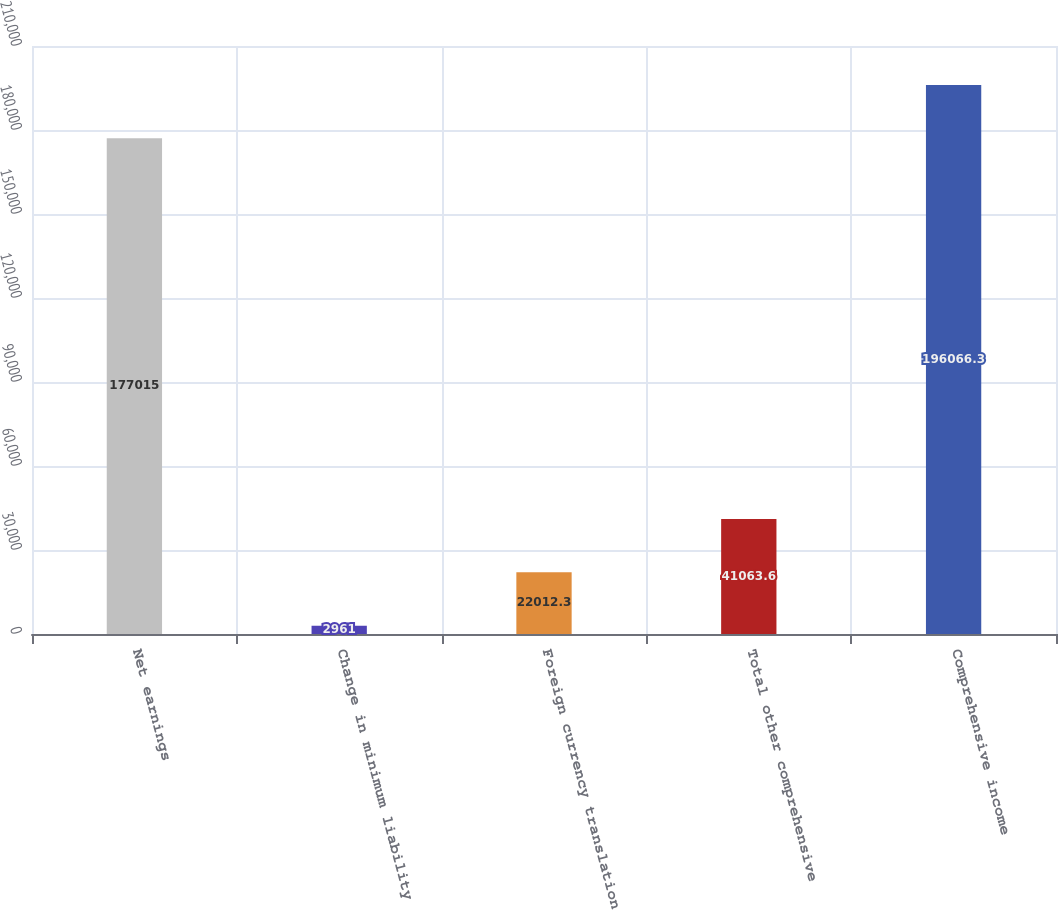Convert chart. <chart><loc_0><loc_0><loc_500><loc_500><bar_chart><fcel>Net earnings<fcel>Change in minimum liability<fcel>Foreign currency translation<fcel>Total other comprehensive<fcel>Comprehensive income<nl><fcel>177015<fcel>2961<fcel>22012.3<fcel>41063.6<fcel>196066<nl></chart> 